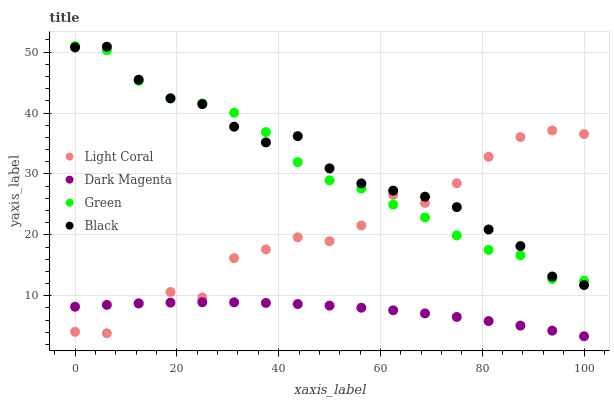Does Dark Magenta have the minimum area under the curve?
Answer yes or no. Yes. Does Black have the maximum area under the curve?
Answer yes or no. Yes. Does Green have the minimum area under the curve?
Answer yes or no. No. Does Green have the maximum area under the curve?
Answer yes or no. No. Is Dark Magenta the smoothest?
Answer yes or no. Yes. Is Light Coral the roughest?
Answer yes or no. Yes. Is Black the smoothest?
Answer yes or no. No. Is Black the roughest?
Answer yes or no. No. Does Dark Magenta have the lowest value?
Answer yes or no. Yes. Does Black have the lowest value?
Answer yes or no. No. Does Green have the highest value?
Answer yes or no. Yes. Does Black have the highest value?
Answer yes or no. No. Is Dark Magenta less than Black?
Answer yes or no. Yes. Is Black greater than Dark Magenta?
Answer yes or no. Yes. Does Green intersect Light Coral?
Answer yes or no. Yes. Is Green less than Light Coral?
Answer yes or no. No. Is Green greater than Light Coral?
Answer yes or no. No. Does Dark Magenta intersect Black?
Answer yes or no. No. 